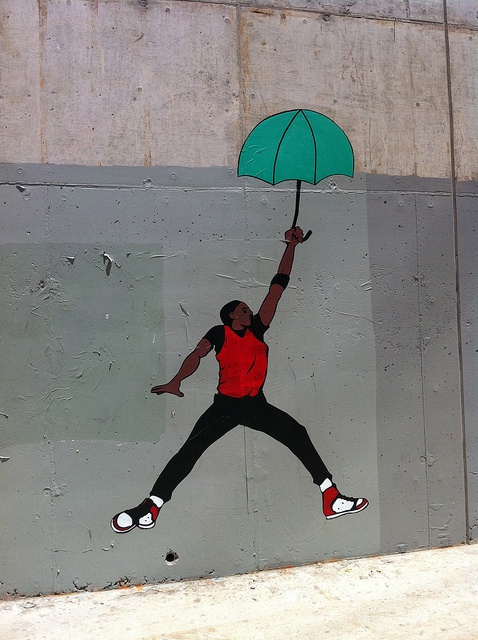Describe the objects in this image and their specific colors. I can see people in gray, black, maroon, and white tones and umbrella in gray, teal, and black tones in this image. 